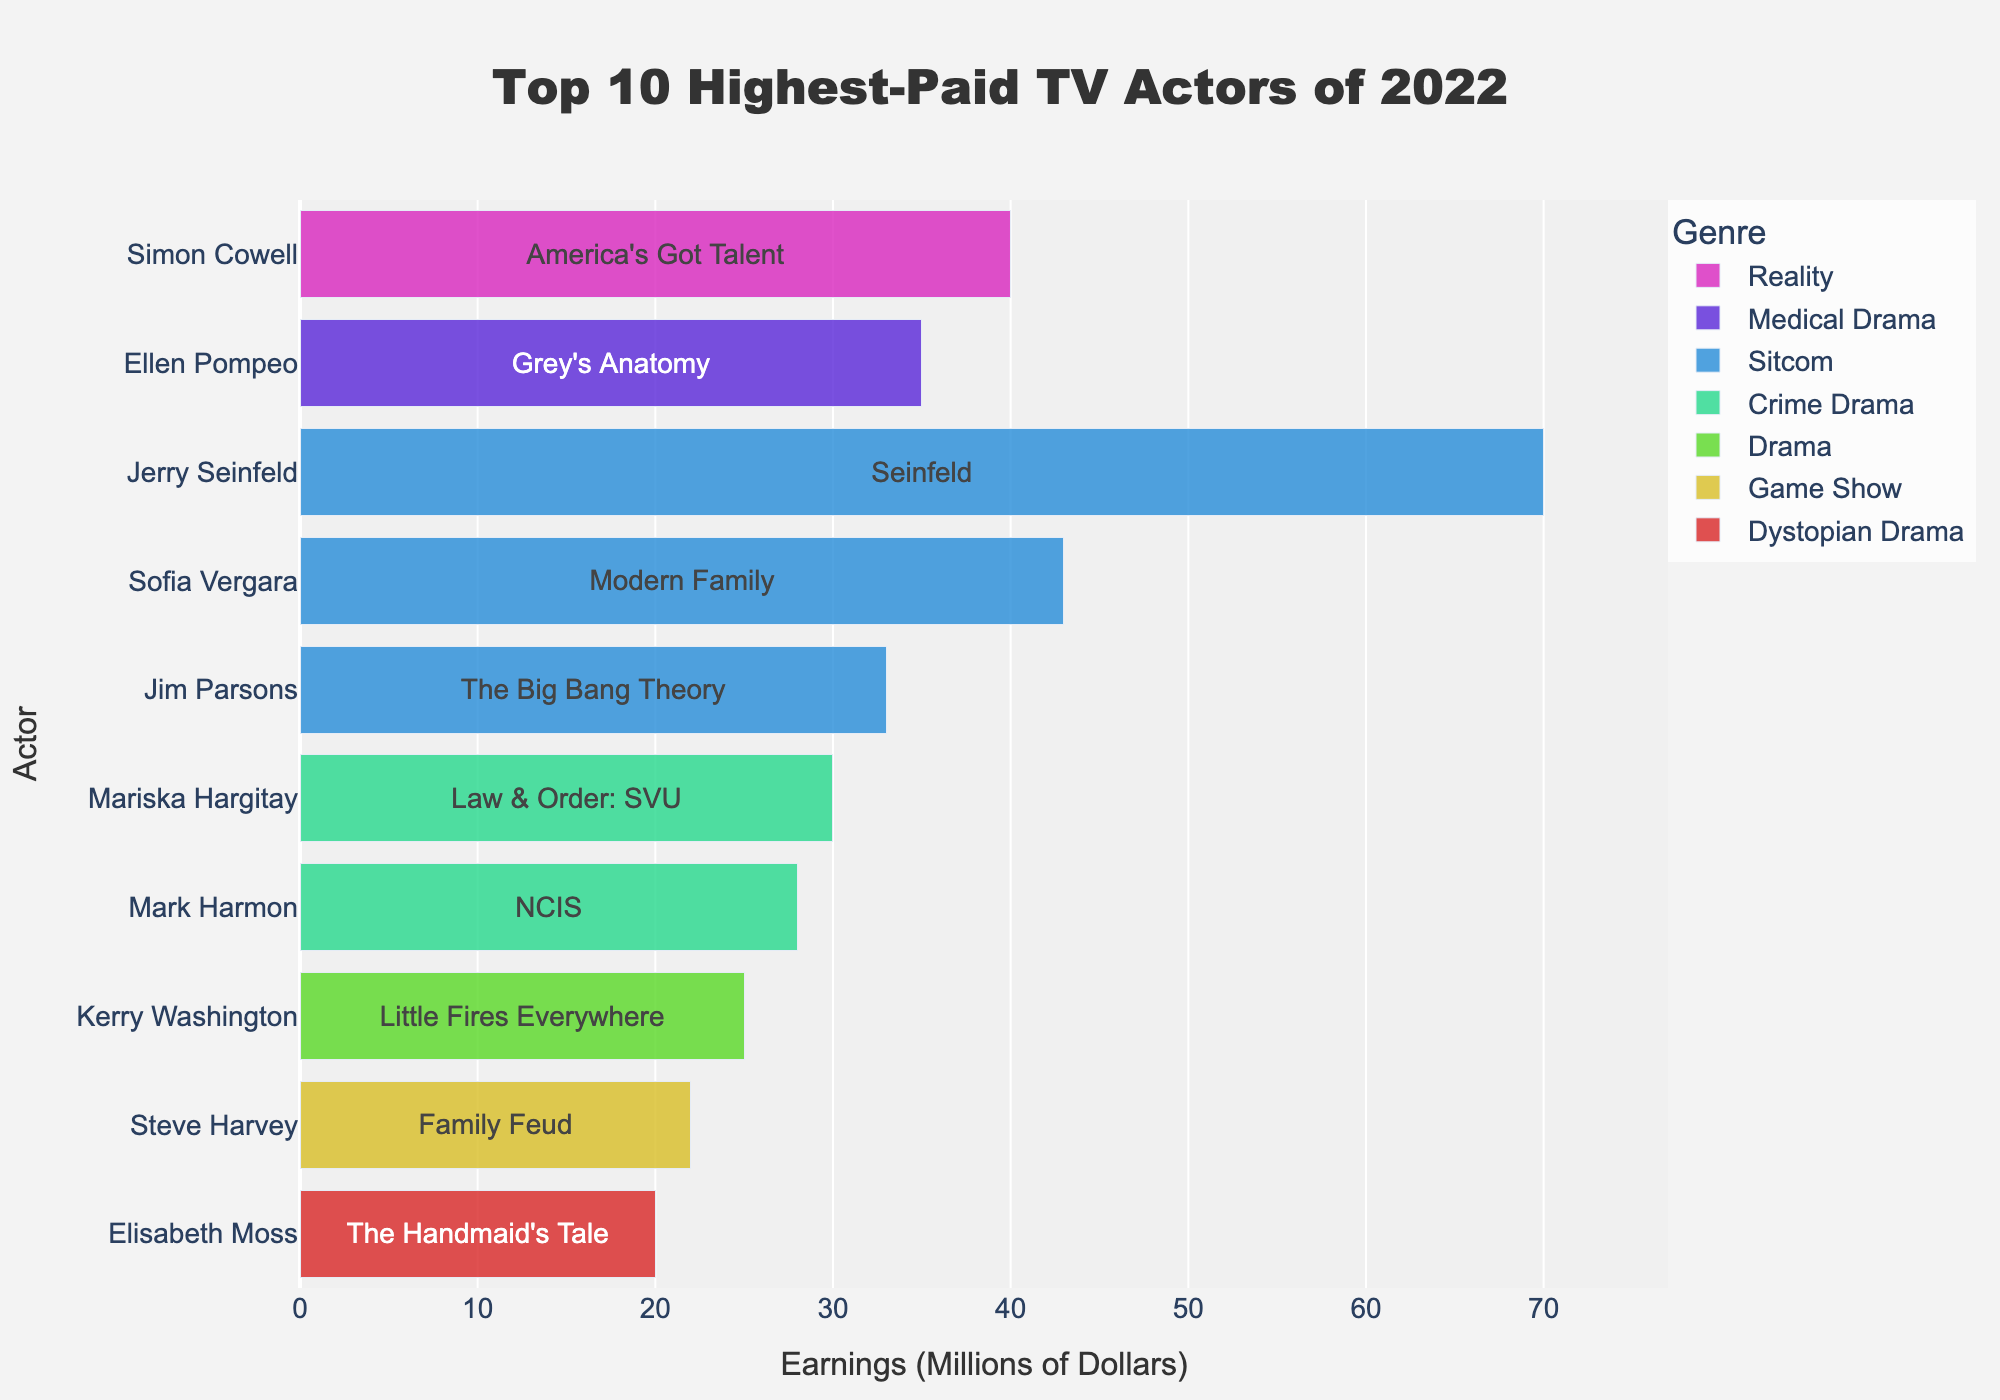which actor has the highest earnings? The bar for Jerry Seinfeld is the longest, indicating the highest earnings.
Answer: Jerry Seinfeld which genre does Sofia Vergara's show belong to? The hover text for Sofia Vergara mentions her show, Modern Family, is a Sitcom.
Answer: Sitcom compare the earnings of Simon Cowell to Jim Parsons; who earns more? Simon Cowell's bar is longer than Jim Parsons', indicating higher earnings.
Answer: Simon Cowell which genre is represented by the green bars? The color of the bars for Jerry Seinfeld, Sofia Vergara, and Jim Parsons is green, and their shows are all Sitcoms.
Answer: Sitcom how many actors in the top 10 highest-paid are from crime dramas? Mariska Hargitay and Mark Harmon are the two actors listed under Crime Drama genre.
Answer: 2 what's the total earnings of actors from medical and crime dramas combined? Ellen Pompeo earns 35 million from medical drama, and Mariska Hargitay and Mark Harmon earn 30 and 28 million respectively from crime drama. Sum = 35 + 30 + 28.
Answer: 93 million which genre has the most actors in the top 10? Sitcom has three actors (Jerry Seinfeld, Sofia Vergara, Jim Parsons).
Answer: Sitcom compare Elisabeth Moss and Kerry Washington in terms of their earnings and genres. Elisabeth Moss earns 20 million and is in Dystopian Drama, while Kerry Washington earns 25 million and is in Drama.
Answer: Kerry Washington earns more and is in Drama how much more does Jerry Seinfeld earn than Steve Harvey? Jerry Seinfeld earns 70 million and Steve Harvey earns 22 million, so the difference is 70 - 22.
Answer: 48 million which actor has the shortest bar indicating their earnings in the figure? Elisabeth Moss's bar is the shortest, indicating the lowest earnings.
Answer: Elisabeth Moss 